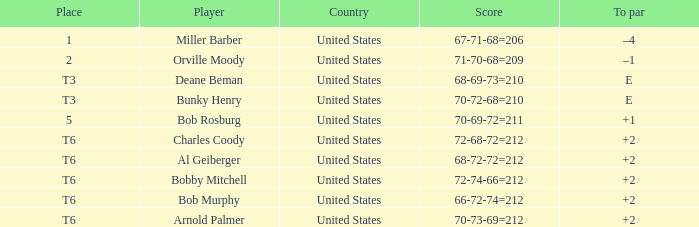What is the place of the 68-69-73=210? T3. 